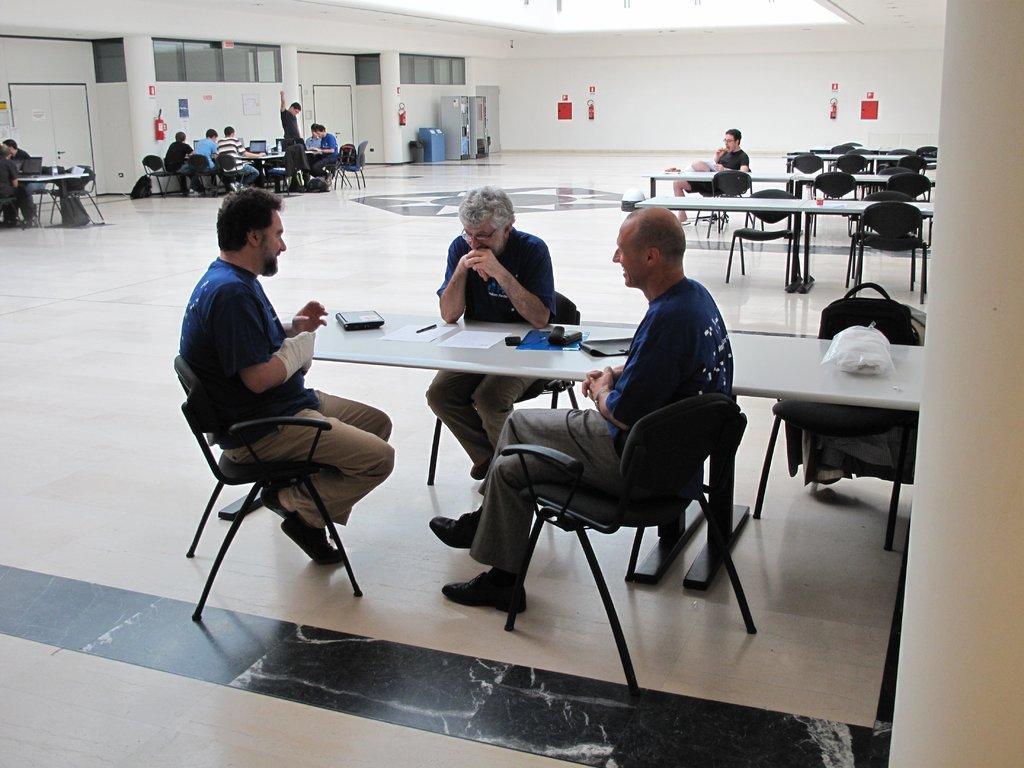Can you describe this image briefly? Here we can see three persons sitting on a chair. They are having a conversation and they are smiling. In the background we can observe a few persons sitting on a chair and they are working on a laptop. Here we can see a few chairs which are empty on the right side. 